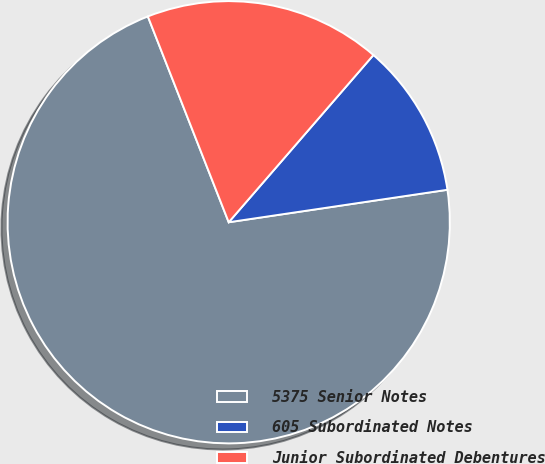Convert chart. <chart><loc_0><loc_0><loc_500><loc_500><pie_chart><fcel>5375 Senior Notes<fcel>605 Subordinated Notes<fcel>Junior Subordinated Debentures<nl><fcel>71.38%<fcel>11.3%<fcel>17.31%<nl></chart> 